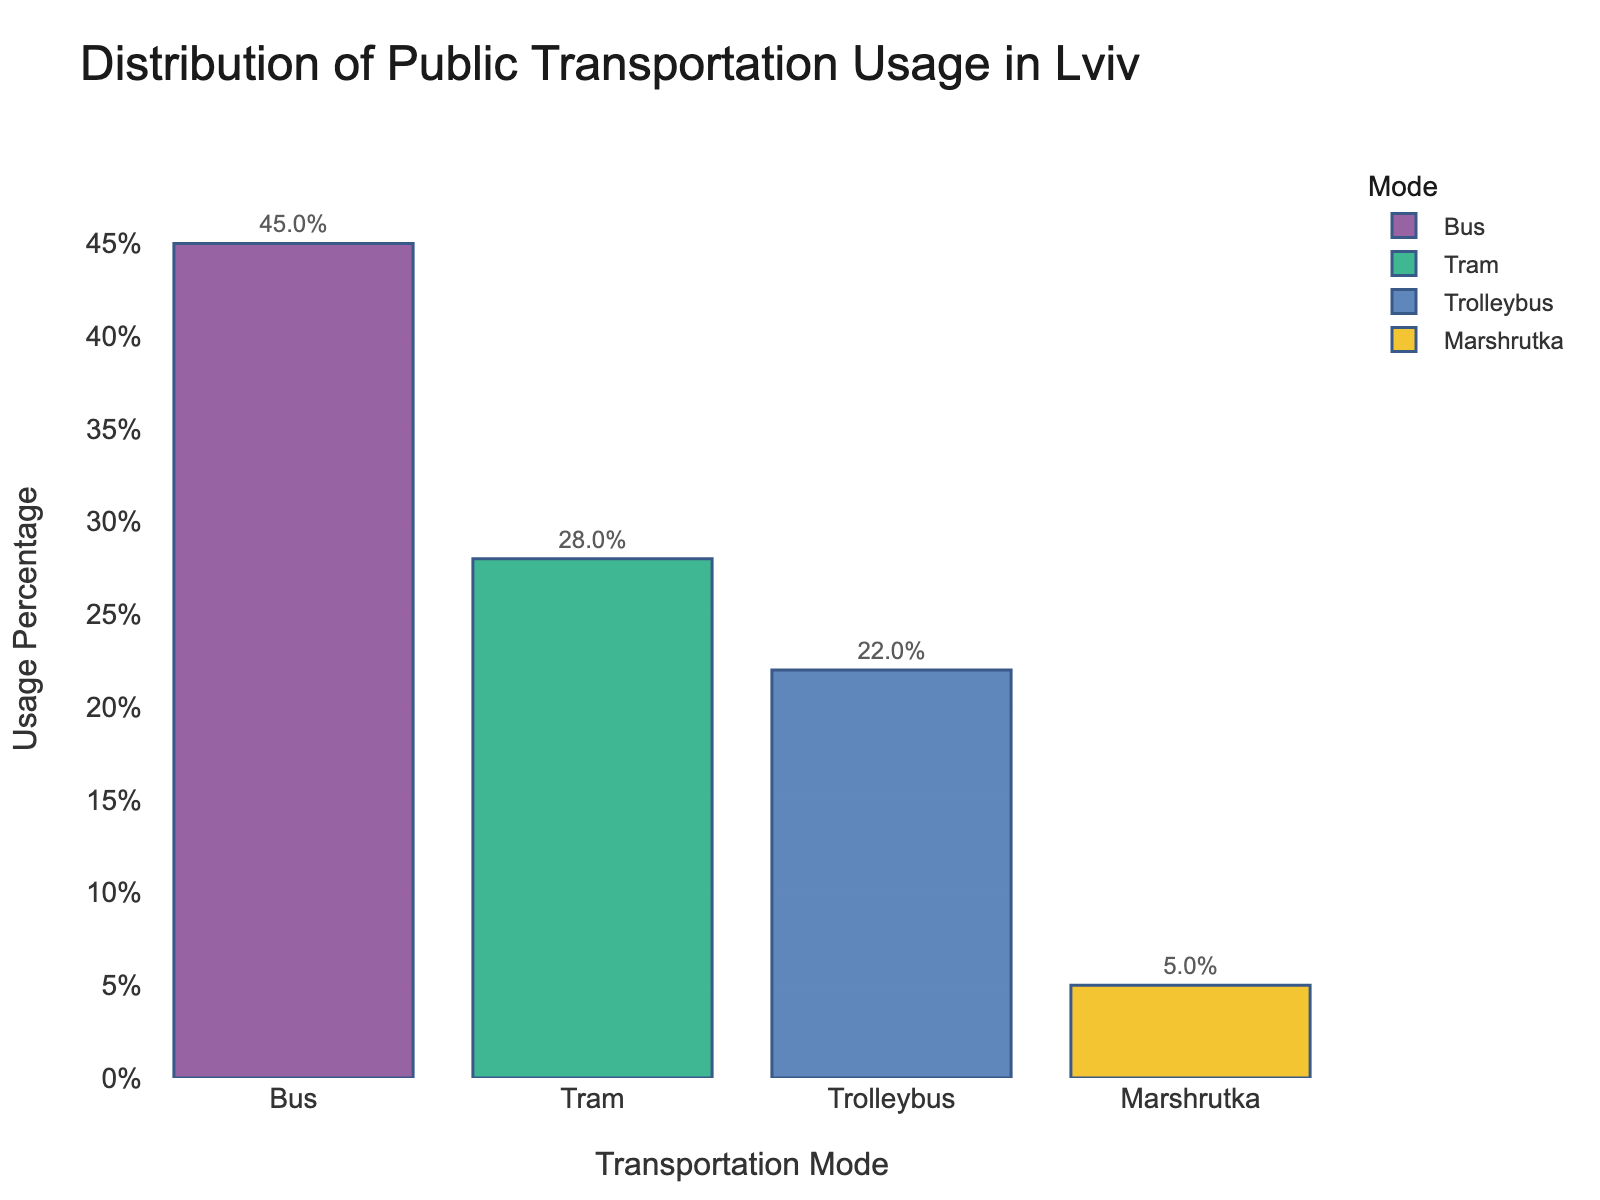What is the mode of transportation with the highest usage percentage? The bar chart indicates the usage percentage for each transportation mode. The tallest bar represents buses, with a percentage of 45%.
Answer: Bus Which mode of transportation has the lowest usage percentage, and what is the percentage? By observing the shortest bar, which is for Marshrutka, you can see that the usage percentage is 5%.
Answer: Marshrutka, 5% How many times higher is the bus usage compared to Marshrutka? The percentage for bus usage is 45% and for Marshrutka is 5%. Dividing 45 by 5 gives us the answer.
Answer: 9 times What is the combined usage percentage for tram and trolleybus? Add the percentage of trams (28%) and trolleybuses (22%) to find the combined usage percentage.
Answer: 50% Which two modes of transportation have the closest usage percentages, and what are these percentages? Comparing the bars, tram and trolleybus have the closest percentages: 28% for tram and 22% for trolleybus.
Answer: Tram and Trolleybus, 28% and 22% How much more popular are buses compared to trams? Subtract the tram usage percentage (28%) from the bus usage percentage (45%) to find the difference.
Answer: 17% If the sum of the usage percentages of all modes is 100%, what percentage is used by the non-electric modes of transportation? Non-electric modes include bus (45%) and Marshrutka (5%). Adding these gives the total percentage.
Answer: 50% Which modes of transportation use electric power, and what is their combined usage percentage? The electric-powered modes are tram and trolleybus. Add their usage percentages: 28% for tram and 22% for trolleybus.
Answer: Tram and Trolleybus, 50% What percentage of public transportation usage in Lviv does not rely on buses? Subtract the bus usage percentage (45%) from 100% to find the percentage that does not rely on buses.
Answer: 55% Which color is used to represent the tram in the bar chart? Observing the bar colors for each mode, the tram is represented by a distinct color. Note this color as seen in the chart.
Answer: (Color of tram bar from chart) 